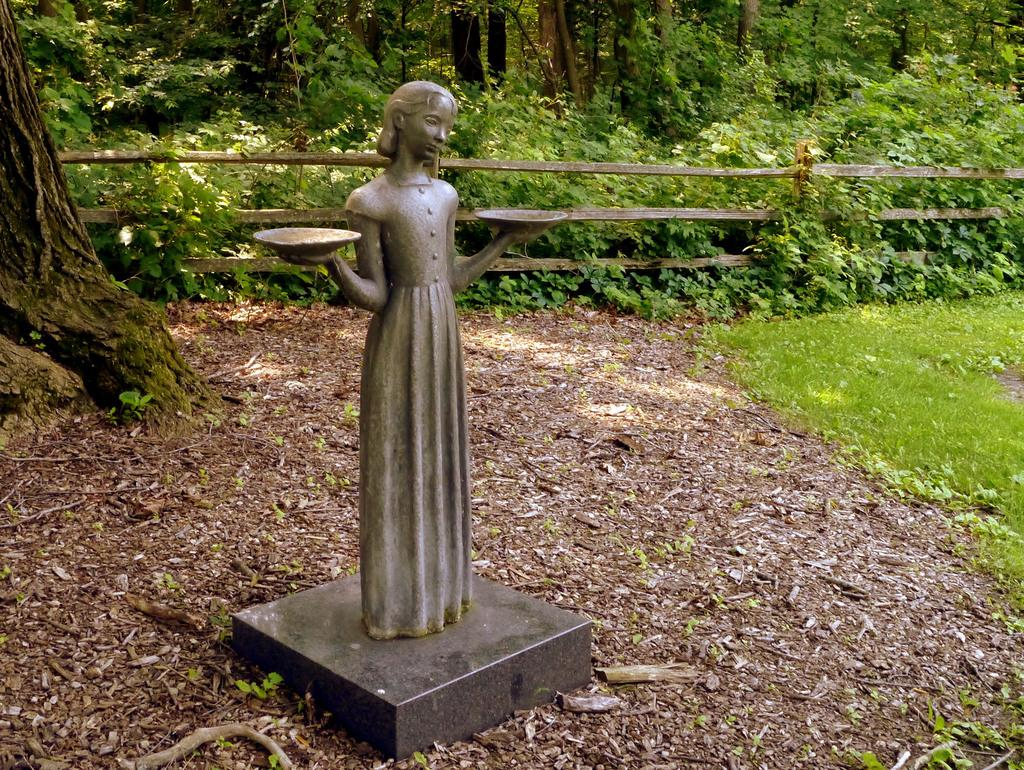What is the main subject of the image? There is a sculpture in the image. Where is the sculpture located? The sculpture is on a land. What can be seen in the background of the image? There are three objects and a wooden railing in the background of the image. What type of boot is being used to stir the stew in the image? There is no boot or stew present in the image; it features a sculpture on a land with objects and a wooden railing in the background. 